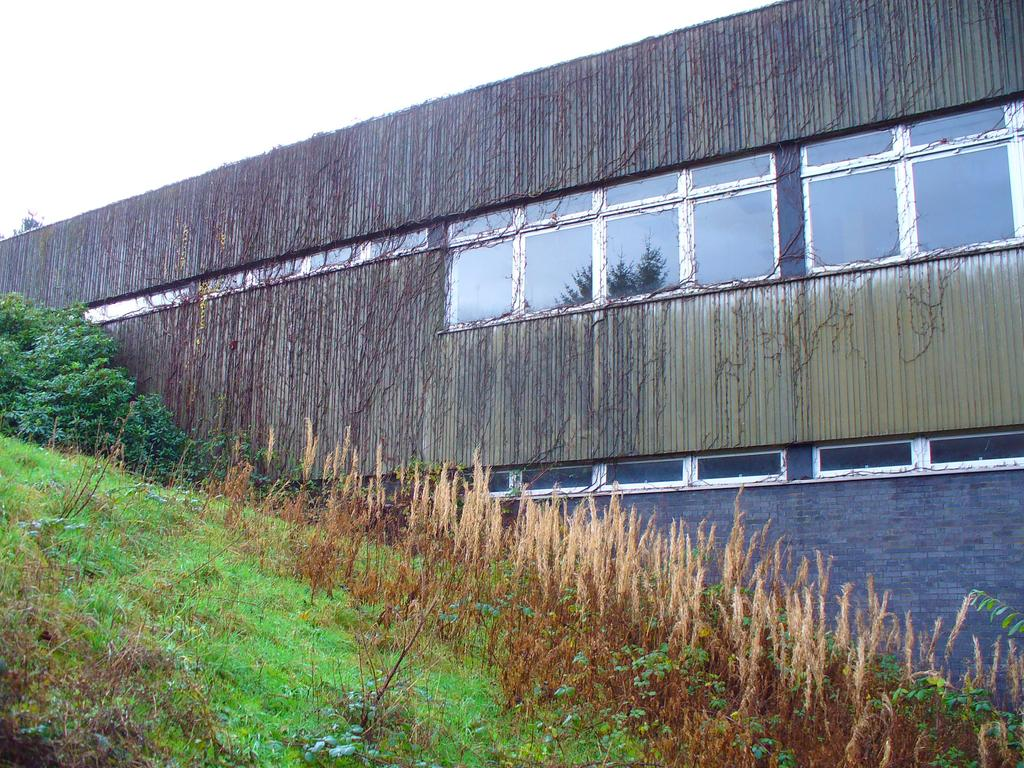What structure is in the image? There is a shed in the image. What feature does the shed have? The shed has windows. What type of vegetation can be seen in the image? There are plants visible in the image. What is the color of the grass in the image? Green grass is present on the ground. What is visible at the top of the image? The sky is visible at the top of the image. How many toes can be seen on the plants in the image? There are no toes present in the image, as plants do not have toes. 